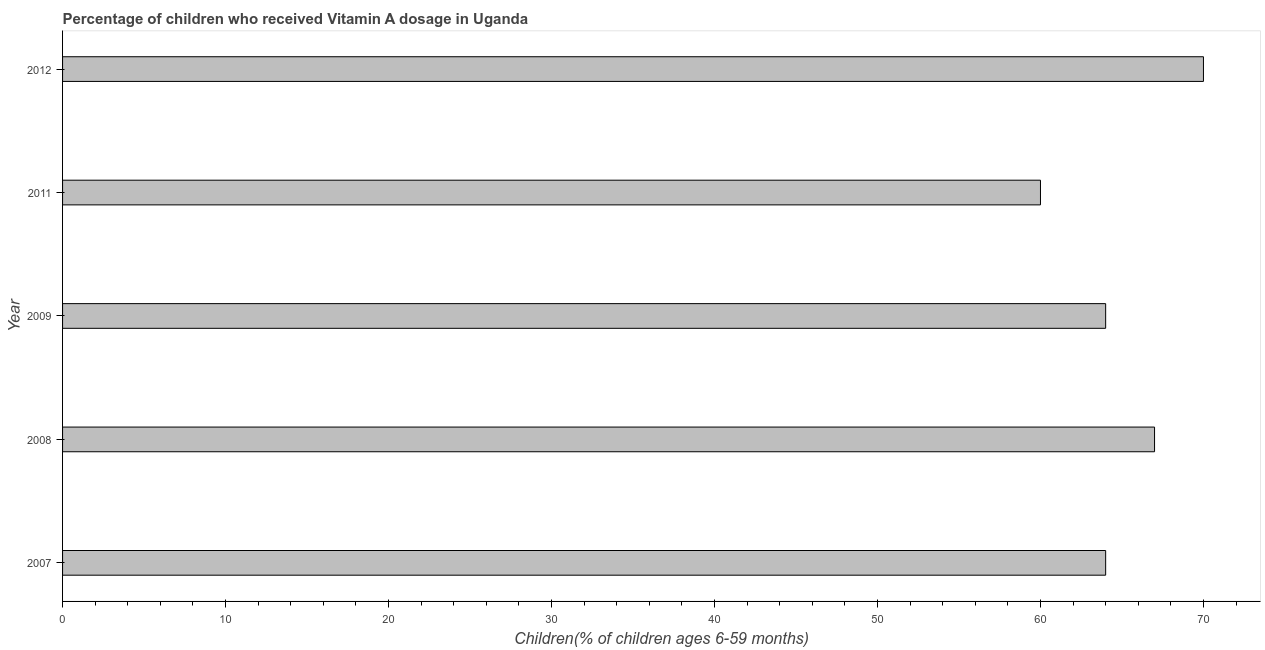Does the graph contain any zero values?
Provide a succinct answer. No. Does the graph contain grids?
Ensure brevity in your answer.  No. What is the title of the graph?
Make the answer very short. Percentage of children who received Vitamin A dosage in Uganda. What is the label or title of the X-axis?
Keep it short and to the point. Children(% of children ages 6-59 months). What is the label or title of the Y-axis?
Your answer should be very brief. Year. What is the vitamin a supplementation coverage rate in 2009?
Your answer should be compact. 64. Across all years, what is the minimum vitamin a supplementation coverage rate?
Ensure brevity in your answer.  60. In which year was the vitamin a supplementation coverage rate minimum?
Ensure brevity in your answer.  2011. What is the sum of the vitamin a supplementation coverage rate?
Provide a short and direct response. 325. What is the ratio of the vitamin a supplementation coverage rate in 2008 to that in 2009?
Offer a very short reply. 1.05. What is the difference between the highest and the second highest vitamin a supplementation coverage rate?
Offer a terse response. 3. Is the sum of the vitamin a supplementation coverage rate in 2008 and 2012 greater than the maximum vitamin a supplementation coverage rate across all years?
Keep it short and to the point. Yes. In how many years, is the vitamin a supplementation coverage rate greater than the average vitamin a supplementation coverage rate taken over all years?
Offer a terse response. 2. How many bars are there?
Keep it short and to the point. 5. How many years are there in the graph?
Provide a succinct answer. 5. What is the difference between two consecutive major ticks on the X-axis?
Your response must be concise. 10. What is the Children(% of children ages 6-59 months) of 2007?
Offer a very short reply. 64. What is the Children(% of children ages 6-59 months) of 2008?
Your answer should be compact. 67. What is the Children(% of children ages 6-59 months) in 2009?
Your response must be concise. 64. What is the Children(% of children ages 6-59 months) in 2011?
Your answer should be very brief. 60. What is the Children(% of children ages 6-59 months) in 2012?
Provide a succinct answer. 70. What is the difference between the Children(% of children ages 6-59 months) in 2007 and 2009?
Your response must be concise. 0. What is the difference between the Children(% of children ages 6-59 months) in 2007 and 2011?
Provide a succinct answer. 4. What is the difference between the Children(% of children ages 6-59 months) in 2007 and 2012?
Your answer should be compact. -6. What is the difference between the Children(% of children ages 6-59 months) in 2008 and 2009?
Give a very brief answer. 3. What is the difference between the Children(% of children ages 6-59 months) in 2009 and 2011?
Your response must be concise. 4. What is the ratio of the Children(% of children ages 6-59 months) in 2007 to that in 2008?
Your response must be concise. 0.95. What is the ratio of the Children(% of children ages 6-59 months) in 2007 to that in 2011?
Ensure brevity in your answer.  1.07. What is the ratio of the Children(% of children ages 6-59 months) in 2007 to that in 2012?
Ensure brevity in your answer.  0.91. What is the ratio of the Children(% of children ages 6-59 months) in 2008 to that in 2009?
Provide a succinct answer. 1.05. What is the ratio of the Children(% of children ages 6-59 months) in 2008 to that in 2011?
Your answer should be compact. 1.12. What is the ratio of the Children(% of children ages 6-59 months) in 2009 to that in 2011?
Offer a very short reply. 1.07. What is the ratio of the Children(% of children ages 6-59 months) in 2009 to that in 2012?
Your answer should be very brief. 0.91. What is the ratio of the Children(% of children ages 6-59 months) in 2011 to that in 2012?
Your response must be concise. 0.86. 